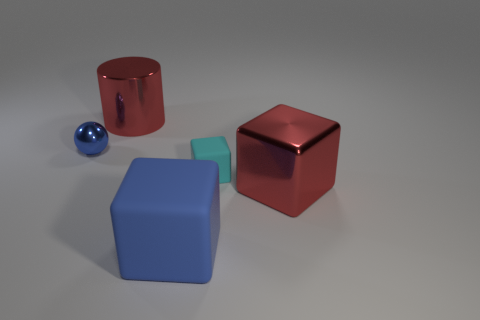What is the color of the small matte cube that is in front of the blue metallic thing that is in front of the red metal cylinder?
Keep it short and to the point. Cyan. There is another red object that is the same shape as the small rubber object; what is it made of?
Your response must be concise. Metal. What number of other blocks have the same size as the blue cube?
Your answer should be very brief. 1. What is the size of the other block that is the same material as the tiny cyan cube?
Offer a terse response. Large. How many large red things are the same shape as the big blue thing?
Provide a succinct answer. 1. How many small rubber cubes are there?
Give a very brief answer. 1. There is a metal object that is behind the blue ball; is its shape the same as the blue matte thing?
Provide a short and direct response. No. What material is the blue thing that is the same size as the metallic block?
Your response must be concise. Rubber. Is there a tiny brown cube made of the same material as the small cyan block?
Keep it short and to the point. No. There is a big blue rubber thing; does it have the same shape as the big metallic thing on the left side of the blue matte object?
Your response must be concise. No. 